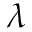<formula> <loc_0><loc_0><loc_500><loc_500>\lambda</formula> 